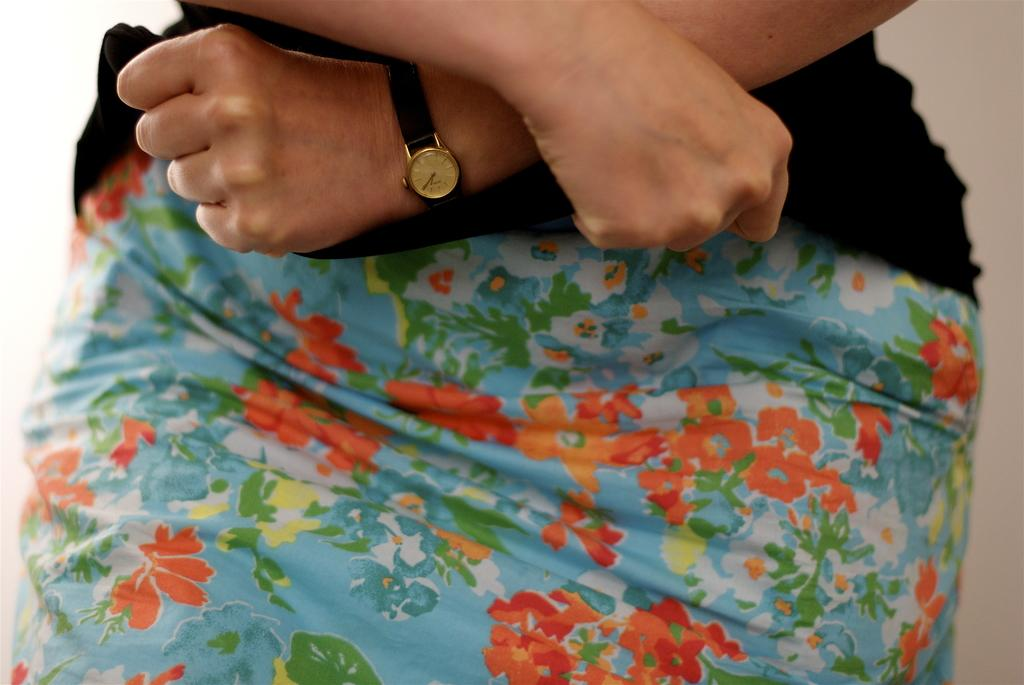What is the main subject of the picture? There is a person in the picture. What accessory is the person wearing? The person is wearing a watch. What type of clothing is the person wearing? The person is wearing clothes with a design of flowers. What type of hook can be seen attached to the person's clothes in the image? There is no hook present on the person's clothes in the image. What is the person using to cook in the image? There is no oven or cooking activity present in the image. 